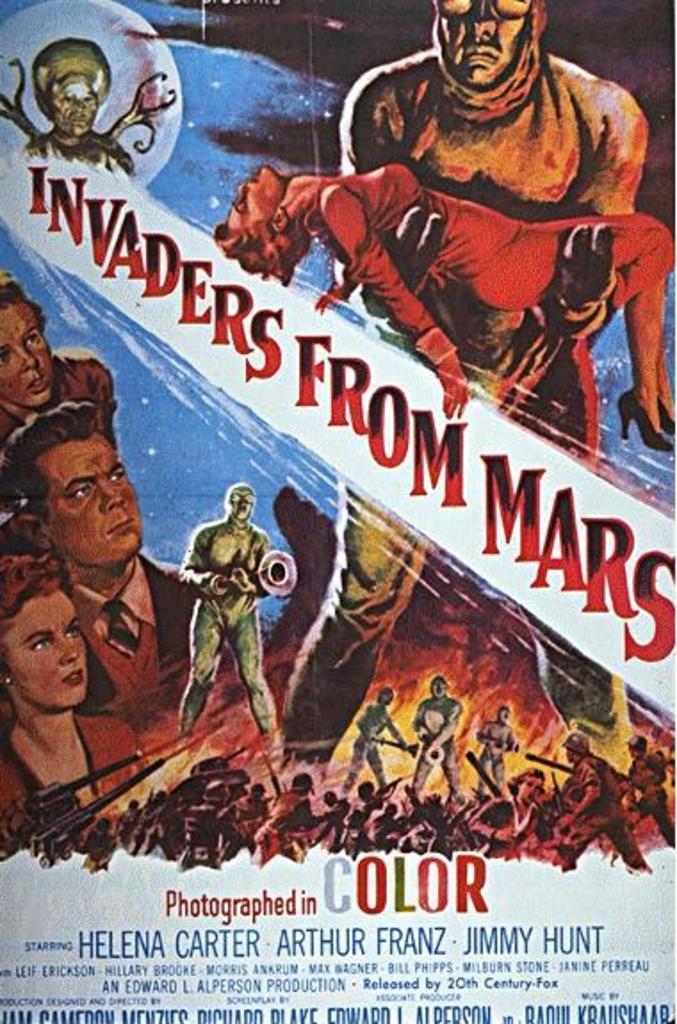What is the name of this movie?
Give a very brief answer. Invaders from mars. 